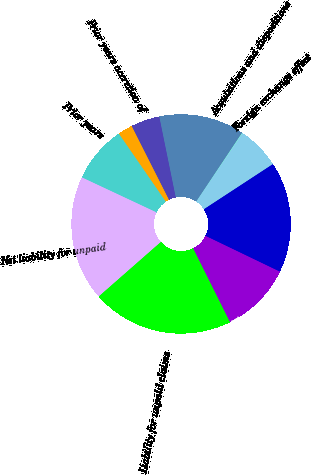Convert chart. <chart><loc_0><loc_0><loc_500><loc_500><pie_chart><fcel>Liability for unpaid claims<fcel>Reinsurance recoverable<fcel>Total<fcel>Foreign exchange effect<fcel>Acquisitions and dispositions<fcel>Current year<fcel>Prior years other than<fcel>Prior years accretion of<fcel>Prior years<fcel>Net liability for unpaid<nl><fcel>20.9%<fcel>10.49%<fcel>16.36%<fcel>6.33%<fcel>0.08%<fcel>12.57%<fcel>4.25%<fcel>2.16%<fcel>8.41%<fcel>18.44%<nl></chart> 